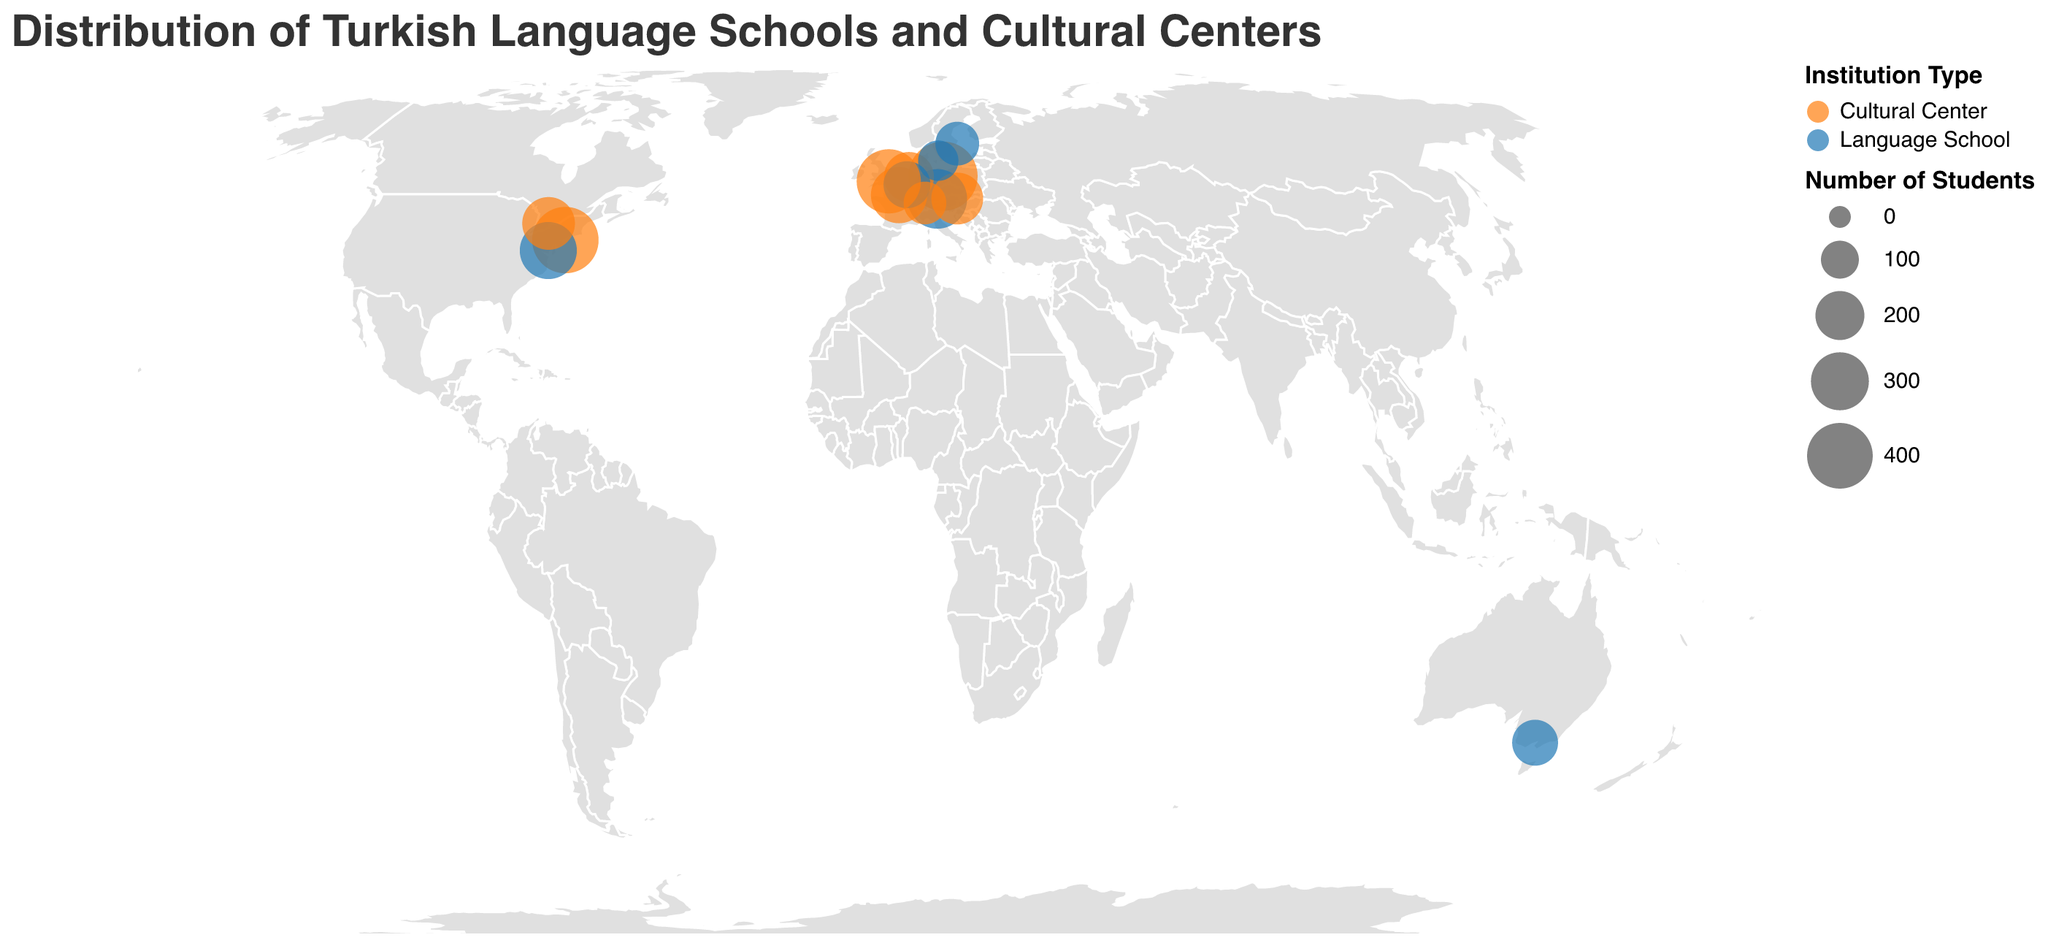What is the title of the figure? The title is usually displayed at the top of the figure and gives an overview of what the plot represents. In this case, it indicates the distribution of Turkish language schools and cultural centers.
Answer: Distribution of Turkish Language Schools and Cultural Centers How many institutions are in Germany? To find the number of institutions in Germany, locate Germany on the map and count the data points associated with it.
Answer: 2 Which city has the highest number of students in cultural centers? Look for the city represented by the largest circle in the color associated with cultural centers.
Answer: Berlin Are there more cultural centers or language schools in the U.S.A.? Examine the data points in the U.S.A. and count the number of circles for each type of institution.
Answer: Cultural centers What is the total number of students in cultural centers across all countries? Sum the number of students in all cultural centers: 450 + 280 + 210 + 230 + 380 + 140 + 410 + 240 = 2340.
Answer: 2340 Which city has the smallest Turkish institution based on the number of students? Identify the city represented by the smallest circle on the map.
Answer: Copenhagen How many institutions are there in total on the figure? Count all the data points on the map.
Answer: 14 Which country has the most institutions shown in the figure? Identify the country with the highest number of data points associated with it.
Answer: U.S.A Compare the number of students in cultural centers versus language schools in Germany. Cultural centers in Germany have 450 students and language schools have 320 students. Subtract the smaller number from the larger number: 450 - 320 = 130.
Answer: 130 more in cultural centers What is the average number of students per institution in Canada? There is only one institution in Canada with 240 students. Therefore, the average is 240/1 = 240.
Answer: 240 